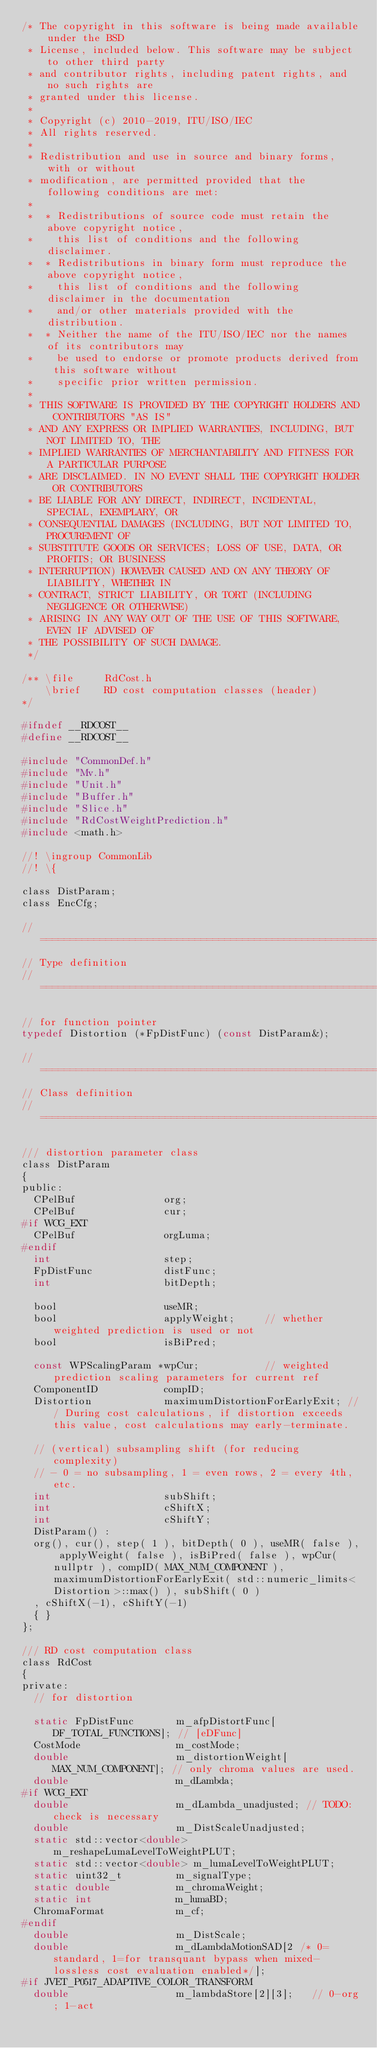Convert code to text. <code><loc_0><loc_0><loc_500><loc_500><_C_>/* The copyright in this software is being made available under the BSD
 * License, included below. This software may be subject to other third party
 * and contributor rights, including patent rights, and no such rights are
 * granted under this license.
 *
 * Copyright (c) 2010-2019, ITU/ISO/IEC
 * All rights reserved.
 *
 * Redistribution and use in source and binary forms, with or without
 * modification, are permitted provided that the following conditions are met:
 *
 *  * Redistributions of source code must retain the above copyright notice,
 *    this list of conditions and the following disclaimer.
 *  * Redistributions in binary form must reproduce the above copyright notice,
 *    this list of conditions and the following disclaimer in the documentation
 *    and/or other materials provided with the distribution.
 *  * Neither the name of the ITU/ISO/IEC nor the names of its contributors may
 *    be used to endorse or promote products derived from this software without
 *    specific prior written permission.
 *
 * THIS SOFTWARE IS PROVIDED BY THE COPYRIGHT HOLDERS AND CONTRIBUTORS "AS IS"
 * AND ANY EXPRESS OR IMPLIED WARRANTIES, INCLUDING, BUT NOT LIMITED TO, THE
 * IMPLIED WARRANTIES OF MERCHANTABILITY AND FITNESS FOR A PARTICULAR PURPOSE
 * ARE DISCLAIMED. IN NO EVENT SHALL THE COPYRIGHT HOLDER OR CONTRIBUTORS
 * BE LIABLE FOR ANY DIRECT, INDIRECT, INCIDENTAL, SPECIAL, EXEMPLARY, OR
 * CONSEQUENTIAL DAMAGES (INCLUDING, BUT NOT LIMITED TO, PROCUREMENT OF
 * SUBSTITUTE GOODS OR SERVICES; LOSS OF USE, DATA, OR PROFITS; OR BUSINESS
 * INTERRUPTION) HOWEVER CAUSED AND ON ANY THEORY OF LIABILITY, WHETHER IN
 * CONTRACT, STRICT LIABILITY, OR TORT (INCLUDING NEGLIGENCE OR OTHERWISE)
 * ARISING IN ANY WAY OUT OF THE USE OF THIS SOFTWARE, EVEN IF ADVISED OF
 * THE POSSIBILITY OF SUCH DAMAGE.
 */

/** \file     RdCost.h
    \brief    RD cost computation classes (header)
*/

#ifndef __RDCOST__
#define __RDCOST__

#include "CommonDef.h"
#include "Mv.h"
#include "Unit.h"
#include "Buffer.h"
#include "Slice.h"
#include "RdCostWeightPrediction.h"
#include <math.h>

//! \ingroup CommonLib
//! \{

class DistParam;
class EncCfg;

// ====================================================================================================================
// Type definition
// ====================================================================================================================

// for function pointer
typedef Distortion (*FpDistFunc) (const DistParam&);

// ====================================================================================================================
// Class definition
// ====================================================================================================================

/// distortion parameter class
class DistParam
{
public:
  CPelBuf               org;
  CPelBuf               cur;
#if WCG_EXT
  CPelBuf               orgLuma;
#endif
  int                   step;
  FpDistFunc            distFunc;
  int                   bitDepth;

  bool                  useMR;
  bool                  applyWeight;     // whether weighted prediction is used or not
  bool                  isBiPred;

  const WPScalingParam *wpCur;           // weighted prediction scaling parameters for current ref
  ComponentID           compID;
  Distortion            maximumDistortionForEarlyExit; /// During cost calculations, if distortion exceeds this value, cost calculations may early-terminate.

  // (vertical) subsampling shift (for reducing complexity)
  // - 0 = no subsampling, 1 = even rows, 2 = every 4th, etc.
  int                   subShift;
  int                   cShiftX;
  int                   cShiftY;
  DistParam() :
  org(), cur(), step( 1 ), bitDepth( 0 ), useMR( false ), applyWeight( false ), isBiPred( false ), wpCur( nullptr ), compID( MAX_NUM_COMPONENT ), maximumDistortionForEarlyExit( std::numeric_limits<Distortion>::max() ), subShift( 0 )
  , cShiftX(-1), cShiftY(-1)
  { }
};

/// RD cost computation class
class RdCost
{
private:
  // for distortion

  static FpDistFunc       m_afpDistortFunc[DF_TOTAL_FUNCTIONS]; // [eDFunc]
  CostMode                m_costMode;
  double                  m_distortionWeight[MAX_NUM_COMPONENT]; // only chroma values are used.
  double                  m_dLambda;
#if WCG_EXT
  double                  m_dLambda_unadjusted; // TODO: check is necessary
  double                  m_DistScaleUnadjusted;
  static std::vector<double> m_reshapeLumaLevelToWeightPLUT;
  static std::vector<double> m_lumaLevelToWeightPLUT;
  static uint32_t         m_signalType;
  static double           m_chromaWeight;
  static int              m_lumaBD;
  ChromaFormat            m_cf;
#endif
  double                  m_DistScale;
  double                  m_dLambdaMotionSAD[2 /* 0=standard, 1=for transquant bypass when mixed-lossless cost evaluation enabled*/];
#if JVET_P0517_ADAPTIVE_COLOR_TRANSFORM
  double                  m_lambdaStore[2][3];   // 0-org; 1-act</code> 